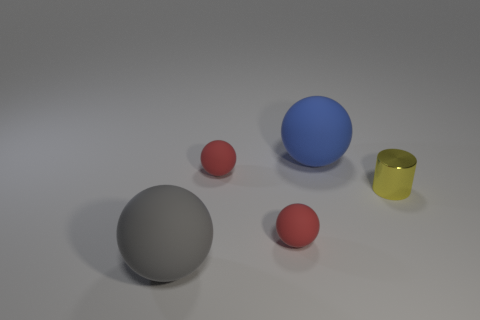Add 4 gray balls. How many objects exist? 9 Subtract all blue spheres. How many spheres are left? 3 Add 5 large gray objects. How many large gray objects are left? 6 Add 3 tiny brown cylinders. How many tiny brown cylinders exist? 3 Subtract 1 yellow cylinders. How many objects are left? 4 Subtract all cylinders. How many objects are left? 4 Subtract 2 balls. How many balls are left? 2 Subtract all cyan cylinders. Subtract all green spheres. How many cylinders are left? 1 Subtract all yellow cylinders. How many gray balls are left? 1 Subtract all big blue cubes. Subtract all small yellow metallic cylinders. How many objects are left? 4 